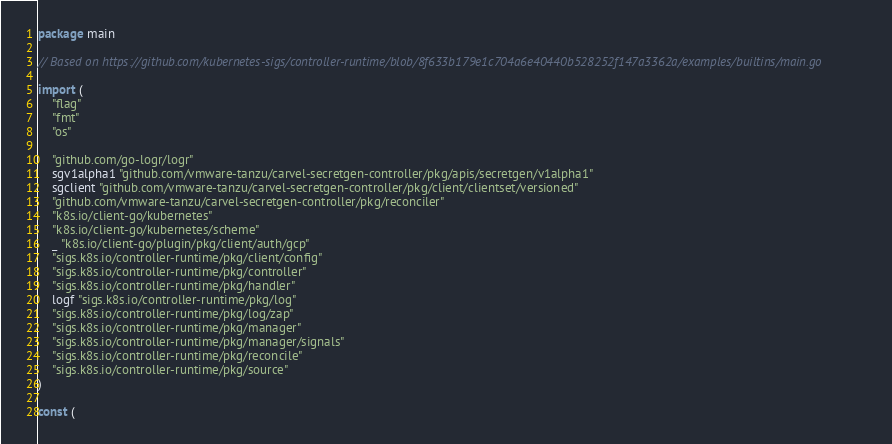Convert code to text. <code><loc_0><loc_0><loc_500><loc_500><_Go_>package main

// Based on https://github.com/kubernetes-sigs/controller-runtime/blob/8f633b179e1c704a6e40440b528252f147a3362a/examples/builtins/main.go

import (
	"flag"
	"fmt"
	"os"

	"github.com/go-logr/logr"
	sgv1alpha1 "github.com/vmware-tanzu/carvel-secretgen-controller/pkg/apis/secretgen/v1alpha1"
	sgclient "github.com/vmware-tanzu/carvel-secretgen-controller/pkg/client/clientset/versioned"
	"github.com/vmware-tanzu/carvel-secretgen-controller/pkg/reconciler"
	"k8s.io/client-go/kubernetes"
	"k8s.io/client-go/kubernetes/scheme"
	_ "k8s.io/client-go/plugin/pkg/client/auth/gcp"
	"sigs.k8s.io/controller-runtime/pkg/client/config"
	"sigs.k8s.io/controller-runtime/pkg/controller"
	"sigs.k8s.io/controller-runtime/pkg/handler"
	logf "sigs.k8s.io/controller-runtime/pkg/log"
	"sigs.k8s.io/controller-runtime/pkg/log/zap"
	"sigs.k8s.io/controller-runtime/pkg/manager"
	"sigs.k8s.io/controller-runtime/pkg/manager/signals"
	"sigs.k8s.io/controller-runtime/pkg/reconcile"
	"sigs.k8s.io/controller-runtime/pkg/source"
)

const (</code> 